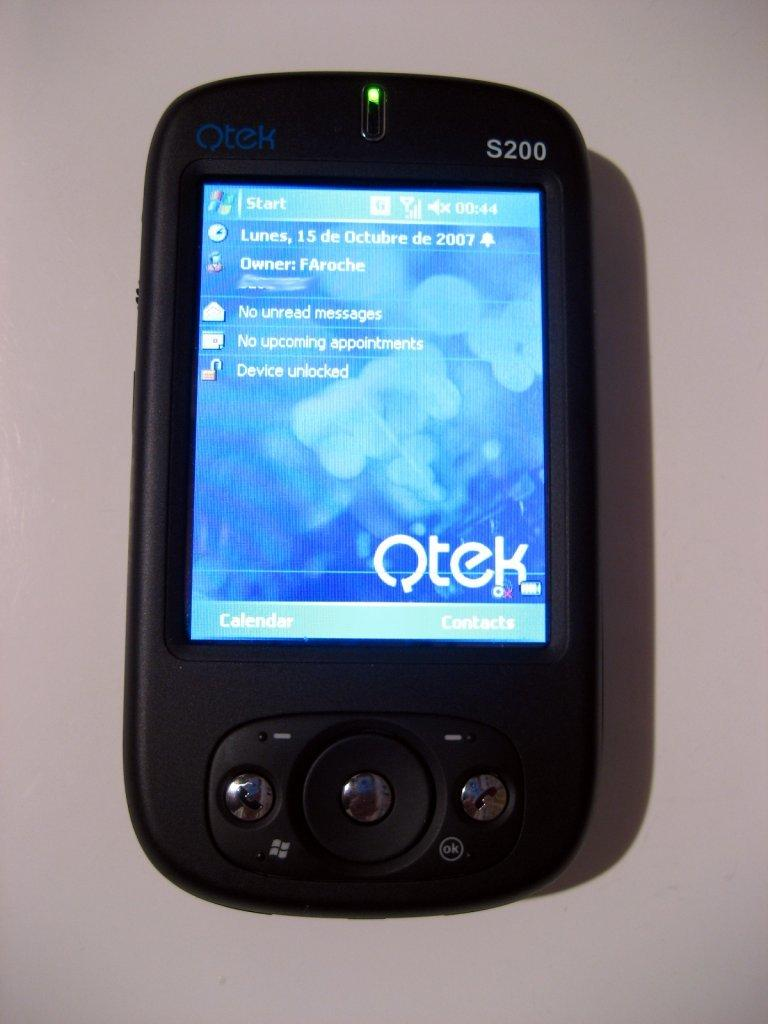Provide a one-sentence caption for the provided image. Small black phone modeled S200 showing the word QTEK on the screen. 